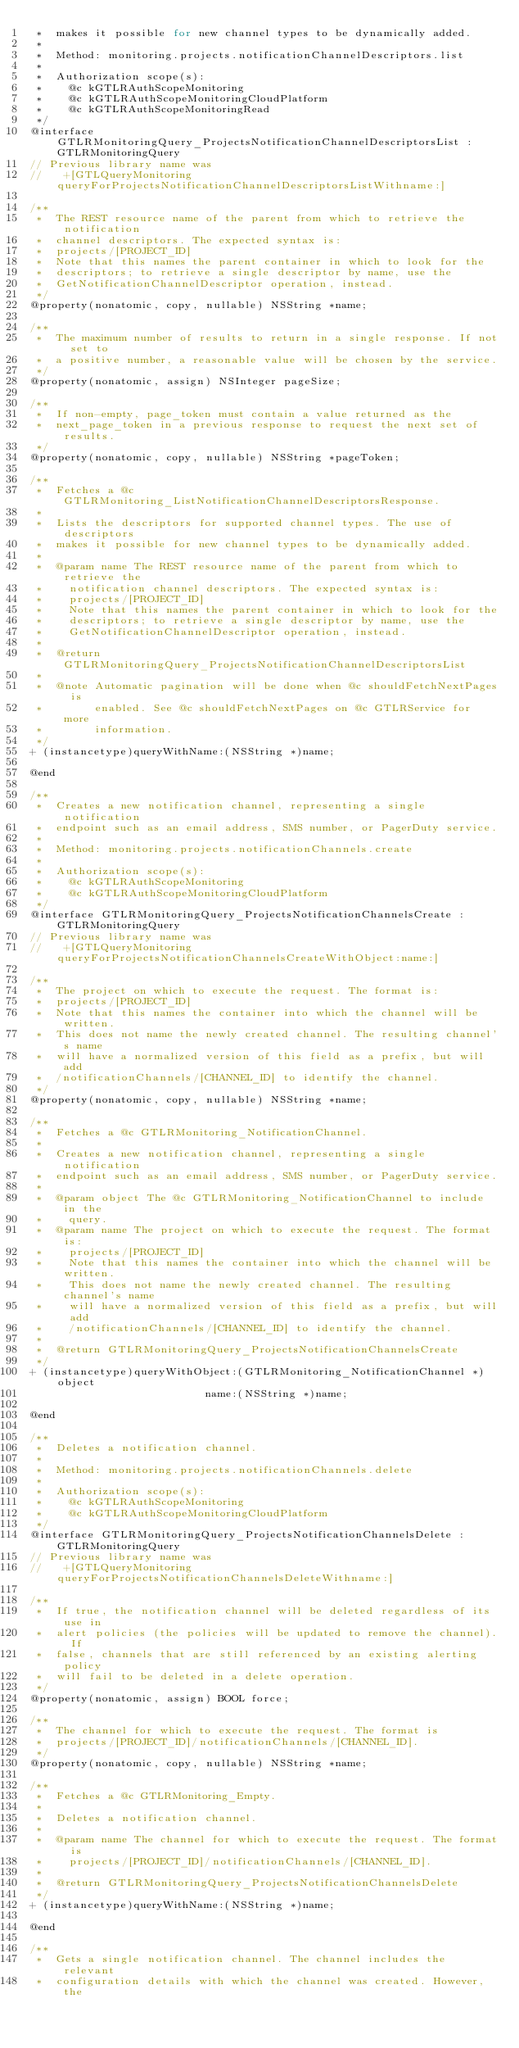Convert code to text. <code><loc_0><loc_0><loc_500><loc_500><_C_> *  makes it possible for new channel types to be dynamically added.
 *
 *  Method: monitoring.projects.notificationChannelDescriptors.list
 *
 *  Authorization scope(s):
 *    @c kGTLRAuthScopeMonitoring
 *    @c kGTLRAuthScopeMonitoringCloudPlatform
 *    @c kGTLRAuthScopeMonitoringRead
 */
@interface GTLRMonitoringQuery_ProjectsNotificationChannelDescriptorsList : GTLRMonitoringQuery
// Previous library name was
//   +[GTLQueryMonitoring queryForProjectsNotificationChannelDescriptorsListWithname:]

/**
 *  The REST resource name of the parent from which to retrieve the notification
 *  channel descriptors. The expected syntax is:
 *  projects/[PROJECT_ID]
 *  Note that this names the parent container in which to look for the
 *  descriptors; to retrieve a single descriptor by name, use the
 *  GetNotificationChannelDescriptor operation, instead.
 */
@property(nonatomic, copy, nullable) NSString *name;

/**
 *  The maximum number of results to return in a single response. If not set to
 *  a positive number, a reasonable value will be chosen by the service.
 */
@property(nonatomic, assign) NSInteger pageSize;

/**
 *  If non-empty, page_token must contain a value returned as the
 *  next_page_token in a previous response to request the next set of results.
 */
@property(nonatomic, copy, nullable) NSString *pageToken;

/**
 *  Fetches a @c GTLRMonitoring_ListNotificationChannelDescriptorsResponse.
 *
 *  Lists the descriptors for supported channel types. The use of descriptors
 *  makes it possible for new channel types to be dynamically added.
 *
 *  @param name The REST resource name of the parent from which to retrieve the
 *    notification channel descriptors. The expected syntax is:
 *    projects/[PROJECT_ID]
 *    Note that this names the parent container in which to look for the
 *    descriptors; to retrieve a single descriptor by name, use the
 *    GetNotificationChannelDescriptor operation, instead.
 *
 *  @return GTLRMonitoringQuery_ProjectsNotificationChannelDescriptorsList
 *
 *  @note Automatic pagination will be done when @c shouldFetchNextPages is
 *        enabled. See @c shouldFetchNextPages on @c GTLRService for more
 *        information.
 */
+ (instancetype)queryWithName:(NSString *)name;

@end

/**
 *  Creates a new notification channel, representing a single notification
 *  endpoint such as an email address, SMS number, or PagerDuty service.
 *
 *  Method: monitoring.projects.notificationChannels.create
 *
 *  Authorization scope(s):
 *    @c kGTLRAuthScopeMonitoring
 *    @c kGTLRAuthScopeMonitoringCloudPlatform
 */
@interface GTLRMonitoringQuery_ProjectsNotificationChannelsCreate : GTLRMonitoringQuery
// Previous library name was
//   +[GTLQueryMonitoring queryForProjectsNotificationChannelsCreateWithObject:name:]

/**
 *  The project on which to execute the request. The format is:
 *  projects/[PROJECT_ID]
 *  Note that this names the container into which the channel will be written.
 *  This does not name the newly created channel. The resulting channel's name
 *  will have a normalized version of this field as a prefix, but will add
 *  /notificationChannels/[CHANNEL_ID] to identify the channel.
 */
@property(nonatomic, copy, nullable) NSString *name;

/**
 *  Fetches a @c GTLRMonitoring_NotificationChannel.
 *
 *  Creates a new notification channel, representing a single notification
 *  endpoint such as an email address, SMS number, or PagerDuty service.
 *
 *  @param object The @c GTLRMonitoring_NotificationChannel to include in the
 *    query.
 *  @param name The project on which to execute the request. The format is:
 *    projects/[PROJECT_ID]
 *    Note that this names the container into which the channel will be written.
 *    This does not name the newly created channel. The resulting channel's name
 *    will have a normalized version of this field as a prefix, but will add
 *    /notificationChannels/[CHANNEL_ID] to identify the channel.
 *
 *  @return GTLRMonitoringQuery_ProjectsNotificationChannelsCreate
 */
+ (instancetype)queryWithObject:(GTLRMonitoring_NotificationChannel *)object
                           name:(NSString *)name;

@end

/**
 *  Deletes a notification channel.
 *
 *  Method: monitoring.projects.notificationChannels.delete
 *
 *  Authorization scope(s):
 *    @c kGTLRAuthScopeMonitoring
 *    @c kGTLRAuthScopeMonitoringCloudPlatform
 */
@interface GTLRMonitoringQuery_ProjectsNotificationChannelsDelete : GTLRMonitoringQuery
// Previous library name was
//   +[GTLQueryMonitoring queryForProjectsNotificationChannelsDeleteWithname:]

/**
 *  If true, the notification channel will be deleted regardless of its use in
 *  alert policies (the policies will be updated to remove the channel). If
 *  false, channels that are still referenced by an existing alerting policy
 *  will fail to be deleted in a delete operation.
 */
@property(nonatomic, assign) BOOL force;

/**
 *  The channel for which to execute the request. The format is
 *  projects/[PROJECT_ID]/notificationChannels/[CHANNEL_ID].
 */
@property(nonatomic, copy, nullable) NSString *name;

/**
 *  Fetches a @c GTLRMonitoring_Empty.
 *
 *  Deletes a notification channel.
 *
 *  @param name The channel for which to execute the request. The format is
 *    projects/[PROJECT_ID]/notificationChannels/[CHANNEL_ID].
 *
 *  @return GTLRMonitoringQuery_ProjectsNotificationChannelsDelete
 */
+ (instancetype)queryWithName:(NSString *)name;

@end

/**
 *  Gets a single notification channel. The channel includes the relevant
 *  configuration details with which the channel was created. However, the</code> 